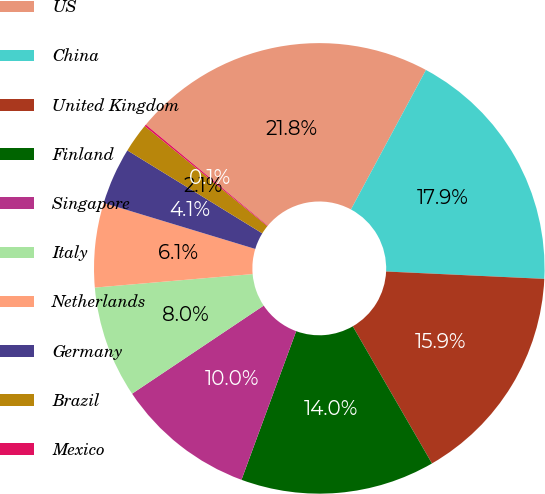Convert chart to OTSL. <chart><loc_0><loc_0><loc_500><loc_500><pie_chart><fcel>US<fcel>China<fcel>United Kingdom<fcel>Finland<fcel>Singapore<fcel>Italy<fcel>Netherlands<fcel>Germany<fcel>Brazil<fcel>Mexico<nl><fcel>21.84%<fcel>17.89%<fcel>15.92%<fcel>13.95%<fcel>10.0%<fcel>8.03%<fcel>6.05%<fcel>4.08%<fcel>2.11%<fcel>0.13%<nl></chart> 